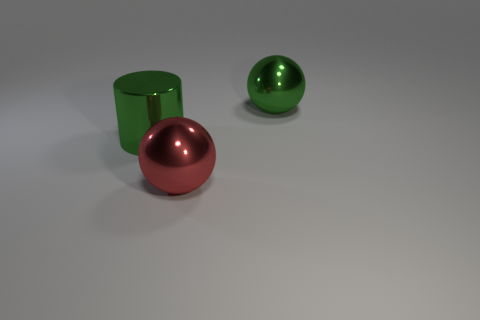There is a big green metal thing right of the red shiny ball; is its shape the same as the shiny thing that is in front of the big green cylinder? The big green object to the right of the red ball is a cylinder, while the shiny object in front of the green cylinder is a sphere, just like the red ball. So, they are not the same shape; one is cylindrical and the other is spherical. 